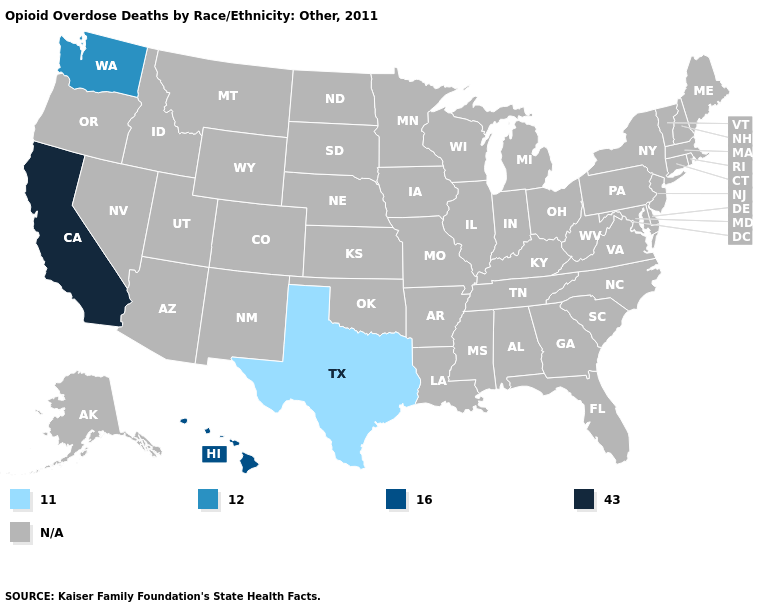What is the value of Massachusetts?
Concise answer only. N/A. What is the value of New York?
Keep it brief. N/A. Does Washington have the highest value in the USA?
Answer briefly. No. What is the value of Idaho?
Write a very short answer. N/A. What is the lowest value in the USA?
Answer briefly. 11.0. What is the value of Nevada?
Write a very short answer. N/A. Among the states that border New Mexico , which have the lowest value?
Give a very brief answer. Texas. Name the states that have a value in the range 11.0?
Concise answer only. Texas. What is the lowest value in the USA?
Answer briefly. 11.0. What is the value of Ohio?
Give a very brief answer. N/A. What is the value of Maryland?
Answer briefly. N/A. Name the states that have a value in the range N/A?
Quick response, please. Alabama, Alaska, Arizona, Arkansas, Colorado, Connecticut, Delaware, Florida, Georgia, Idaho, Illinois, Indiana, Iowa, Kansas, Kentucky, Louisiana, Maine, Maryland, Massachusetts, Michigan, Minnesota, Mississippi, Missouri, Montana, Nebraska, Nevada, New Hampshire, New Jersey, New Mexico, New York, North Carolina, North Dakota, Ohio, Oklahoma, Oregon, Pennsylvania, Rhode Island, South Carolina, South Dakota, Tennessee, Utah, Vermont, Virginia, West Virginia, Wisconsin, Wyoming. What is the highest value in the West ?
Quick response, please. 43.0. 